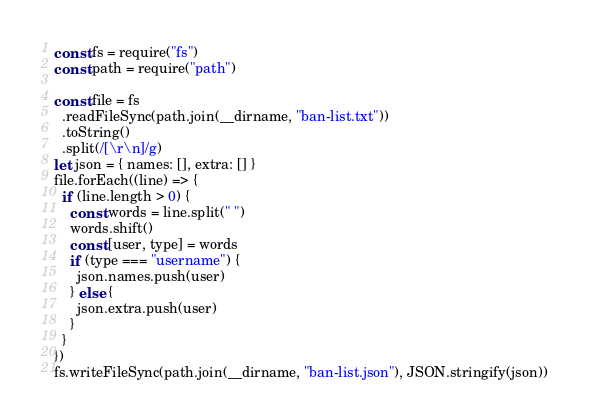Convert code to text. <code><loc_0><loc_0><loc_500><loc_500><_JavaScript_>const fs = require("fs")
const path = require("path")

const file = fs
  .readFileSync(path.join(__dirname, "ban-list.txt"))
  .toString()
  .split(/[\r\n]/g)
let json = { names: [], extra: [] }
file.forEach((line) => {
  if (line.length > 0) {
    const words = line.split(" ")
    words.shift()
    const [user, type] = words
    if (type === "username") {
      json.names.push(user)
    } else {
      json.extra.push(user)
    }
  }
})
fs.writeFileSync(path.join(__dirname, "ban-list.json"), JSON.stringify(json))
</code> 